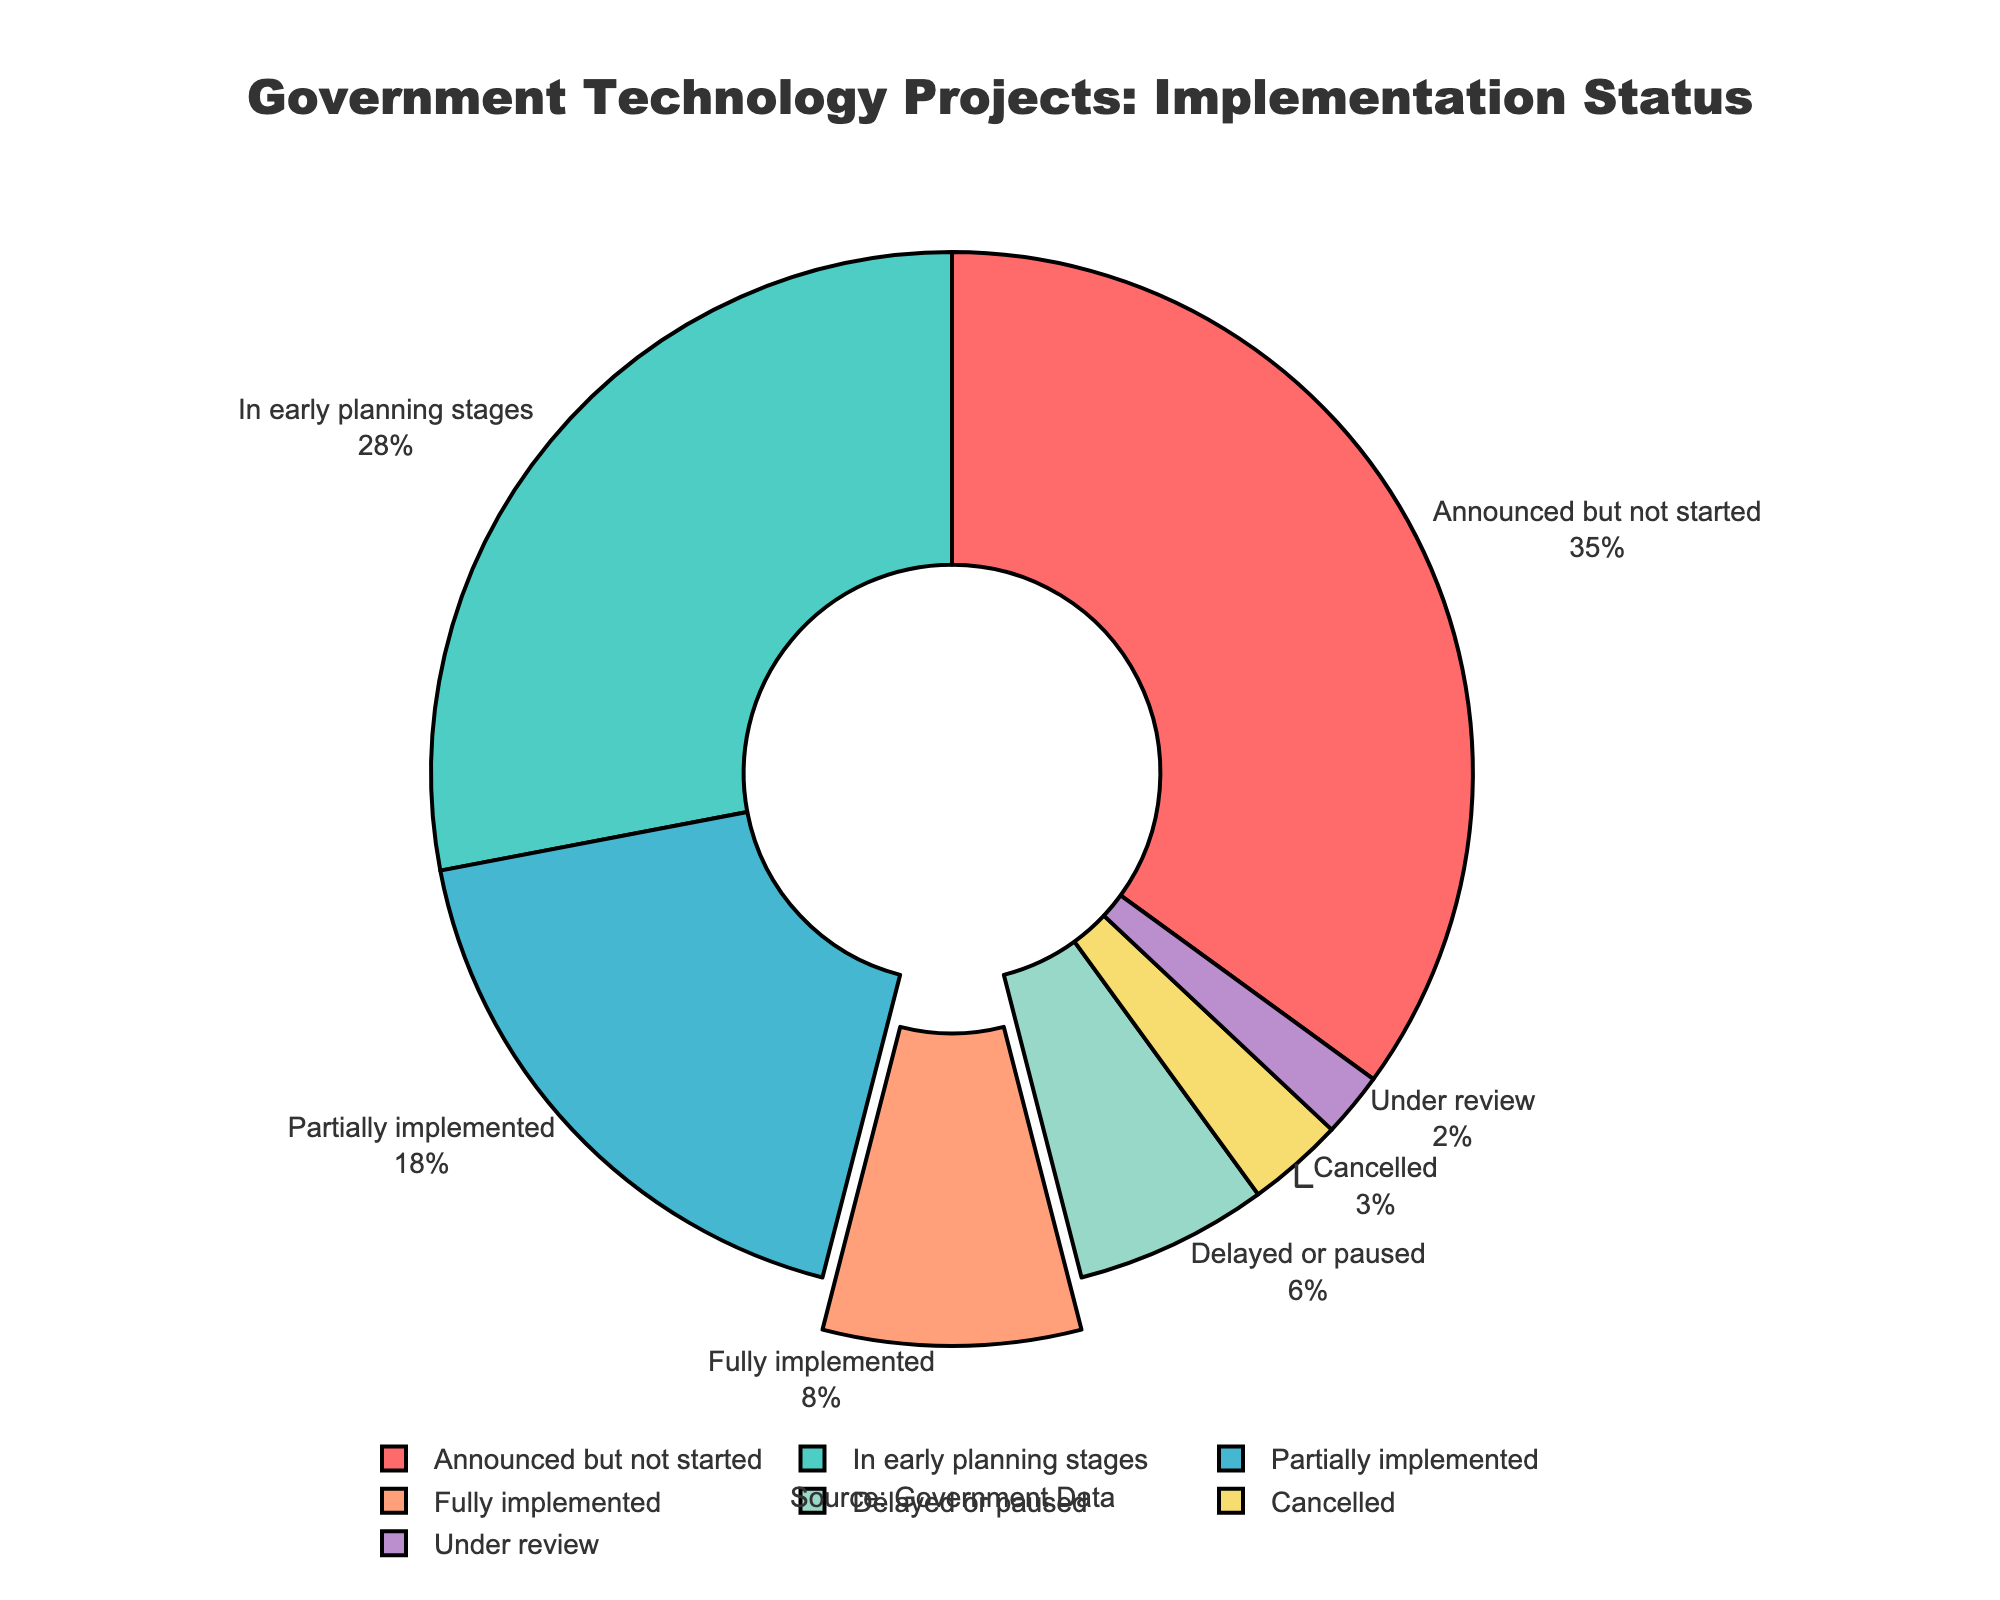What percentage of projects are in early planning stages and delayed or paused combined? To find the combined percentage of projects in early planning stages and delayed or paused, add the percentages of these two categories: 28% (early planning stages) + 6% (delayed or paused).
Answer: 34% Which status has the smallest percentage and what is it? To identify the status with the smallest percentage, look for the smallest value among the percentages. The smallest value is 2%, which corresponds to the status 'Under review'.
Answer: Under review, 2% How many times greater is the percentage of 'Announced but not started' projects compared to 'Cancelled' ones? To determine how many times greater, divide the percentage of 'Announced but not started' projects (35%) by the percentage of 'Cancelled' projects (3%): 35 / 3 = 11.67.
Answer: 11.67 Which status is marked by a different pull effect in the chart, and what is its percentage? The status marked by a different pull effect in the pie chart is 'Fully implemented', which is visually pulled out slightly from the chart. Reviewing the percentages, 'Fully implemented' is 8%.
Answer: Fully implemented, 8% What is the difference in percentage between 'Partially implemented' and 'Announced but not started' projects? Calculate the difference in percentage by subtracting the percentage of 'Partially implemented' projects (18%) from 'Announced but not started' projects (35%): 35 - 18 = 17.
Answer: 17% What status had more than one-fourth but less than one-third of the projects? To find the status with more than 25% but less than 33.33%, refer to the percentages in the chart. 'In early planning stages' has 28%, which fits the criterion.
Answer: In early planning stages How many statuses represent less than 10% each of the total projects? To determine how many statuses have less than 10%, count all categories with percentages below 10%: 'Fully implemented' (8%), 'Delayed or paused' (6%), 'Cancelled' (3%), 'Under review' (2%) make four such statuses.
Answer: 4 What percentage of the projects are either 'Cancelled' or 'Under review'? Add the percentages of 'Cancelled' projects and 'Under review' projects: 3% (Cancelled) + 2% (Under review) = 5%.
Answer: 5% 